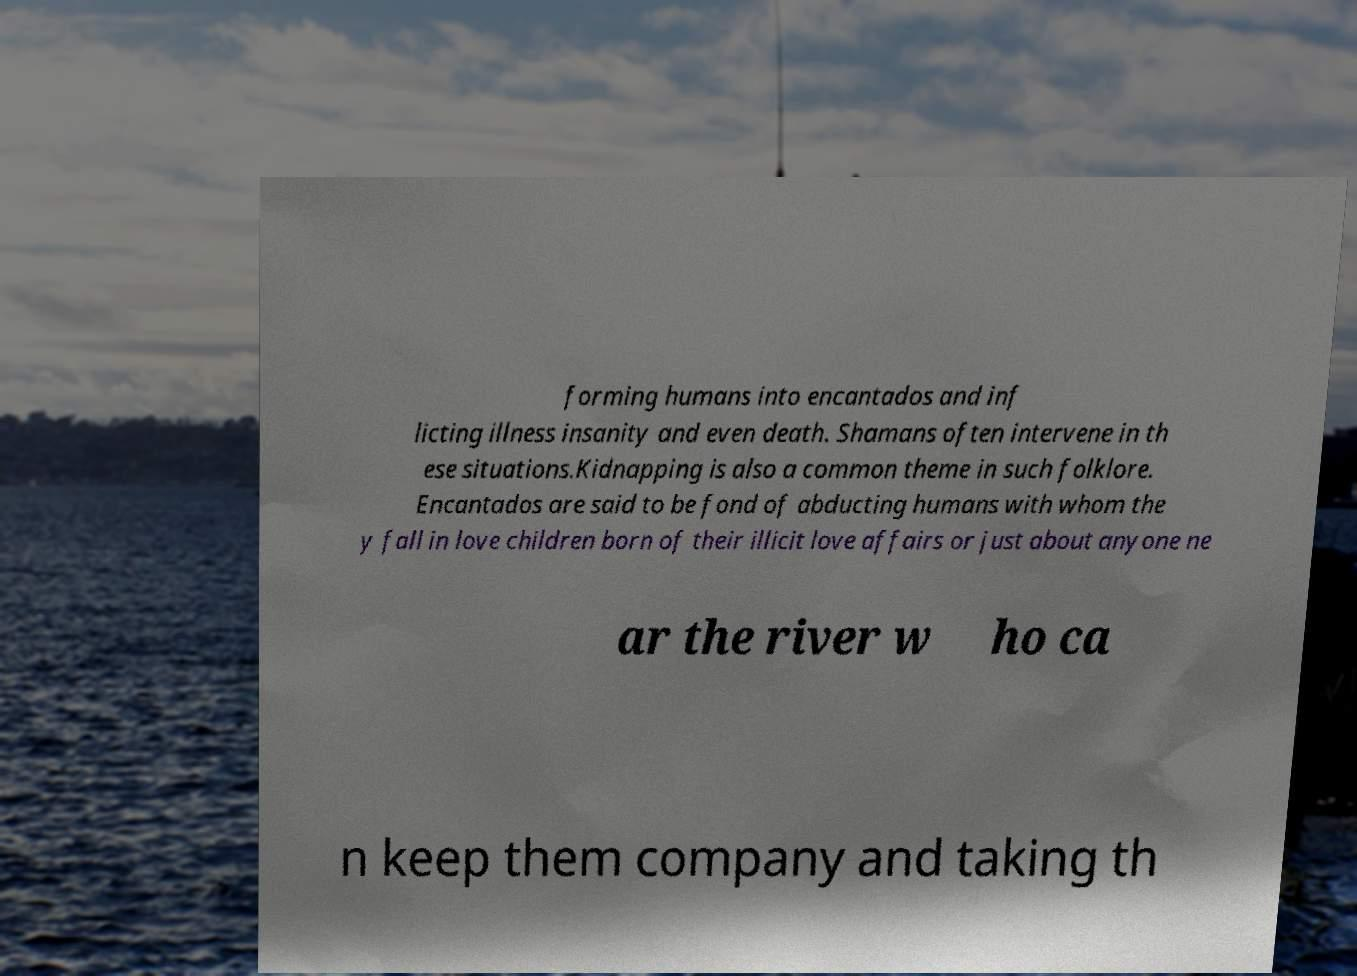What messages or text are displayed in this image? I need them in a readable, typed format. forming humans into encantados and inf licting illness insanity and even death. Shamans often intervene in th ese situations.Kidnapping is also a common theme in such folklore. Encantados are said to be fond of abducting humans with whom the y fall in love children born of their illicit love affairs or just about anyone ne ar the river w ho ca n keep them company and taking th 